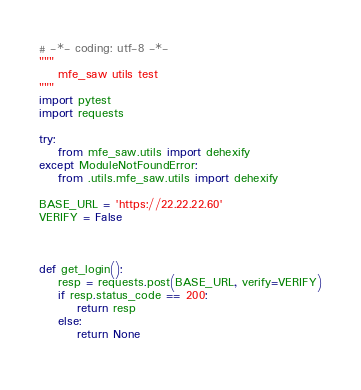Convert code to text. <code><loc_0><loc_0><loc_500><loc_500><_Python_># -*- coding: utf-8 -*-
"""
    mfe_saw utils test
"""
import pytest
import requests

try:
    from mfe_saw.utils import dehexify
except ModuleNotFoundError:
    from .utils.mfe_saw.utils import dehexify

BASE_URL = 'https://22.22.22.60'
VERIFY = False



def get_login():
    resp = requests.post(BASE_URL, verify=VERIFY)
    if resp.status_code == 200:
        return resp
    else:
        return None
    </code> 